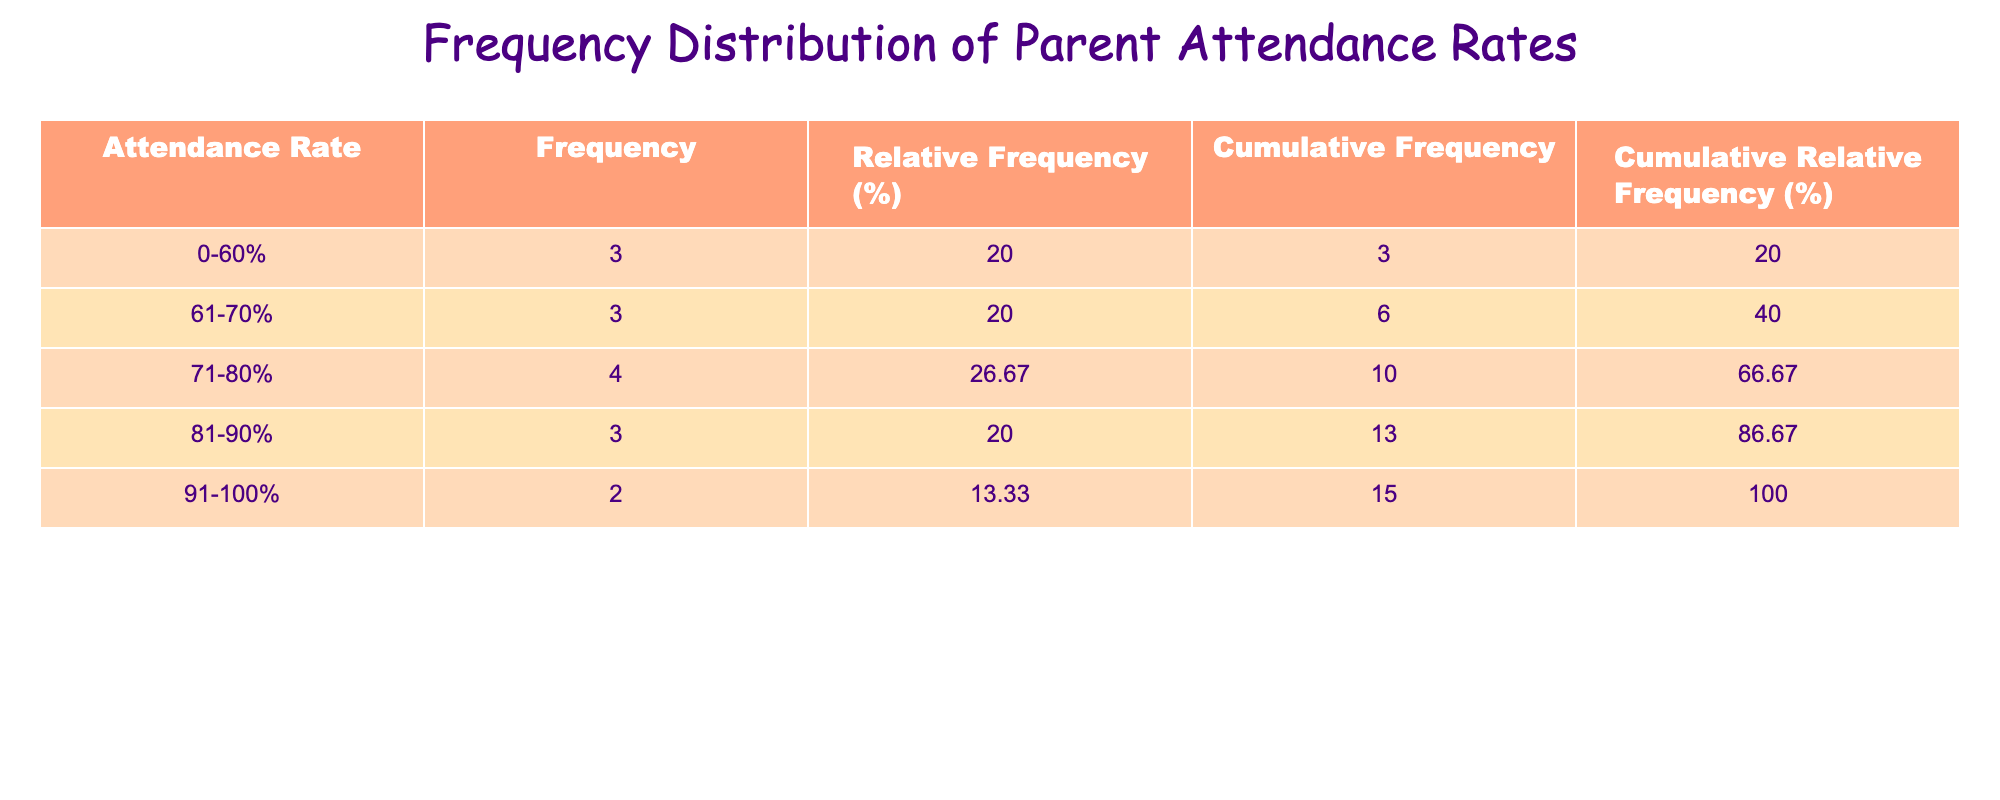What is the frequency of parents who have an attendance rate of 90-100%? According to the table, the attendance rate category for 91-100% includes two parents: Emily Wilson (95) and Amanda Anderson (100). Therefore, the frequency is 2.
Answer: 2 What is the total relative frequency percentage for parents whose attendance rates are less than 70%? The attendance categories of 0-60% and 61-70% have relative frequencies of 14.29% and 14.29%, respectively. Adding these gives 14.29% + 14.29% = 28.58%.
Answer: 28.58% How many parents have an attendance rate in the 71-80% range? The attendance rate category of 71-80% includes three parents: Jessica Taylor (80), Karen Young (80), and Anna Allen (75). Thus, there are 3 parents in this category.
Answer: 3 Is there any parent with an attendance rate below 55%? Looking at the attendance rates presented, the lowest attendance rate recorded is 50% (Brian Miller). Thus, it can be concluded that there is one parent below 55%.
Answer: Yes What is the cumulative frequency for parents with an attendance rate of 81-90%? The cumulative frequency is determined by summing the frequencies for attendance categories 0-60%, 61-70%, 71-80%, and 81-90%. For the categories, we have: 2 (0-60%) + 2 (61-70%) + 3 (71-80%) + 4 (81-90%) = 11.
Answer: 11 What is the average attendance rate for parents in the 70-80% category? The attendance rates for parents in the 71-80% category are 80, 80, and 75 (from Jessica Taylor, Karen Young, and Anna Allen). To find the average, we add these values together: 80 + 80 + 75 = 235. Then divide by the number of parents: 235/3 = 78.33.
Answer: 78.33 How many parents have attendance rates above 70%? The categories above 70% are 71-80%, 81-90%, and 91-100%. Summing the frequencies for these ranges: 3 (71-80%) + 4 (81-90%) + 2 (91-100%) = 9. Thus, 9 parents have attendance rates above 70%.
Answer: 9 What percentage of parents have attendance rates between 61% and 80%? The frequency of parents in the 61-70% category is 2, and in the 71-80% category, it is 3. Thus, a total of 5 parents fall within these categories. To calculate the percentage: (5/14) * 100 = 35.71%.
Answer: 35.71% Is the attendance distribution balanced among the parents? The distribution shows that more parents are clustered within the higher attendance rates (e.g., 80% and above) than in the lower rates. This indicates an imbalance favoring higher attendance.
Answer: No 